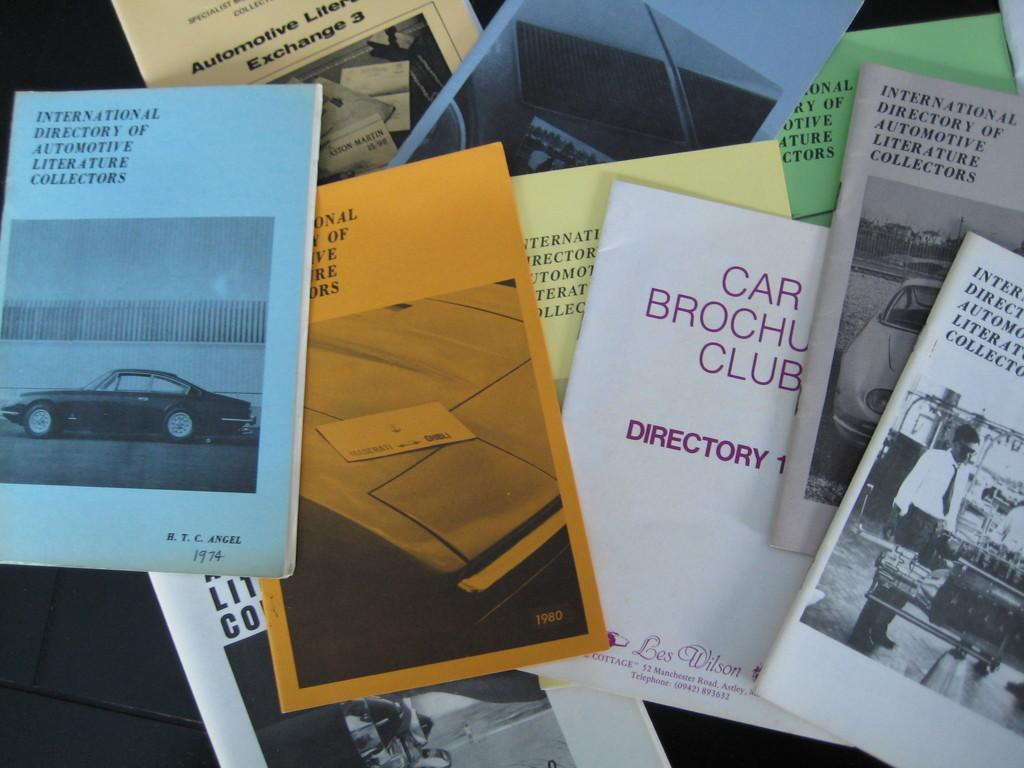<image>
Relay a brief, clear account of the picture shown. A bunch of pamphlets rest on a laptop including one titled Car Brochure Club. 